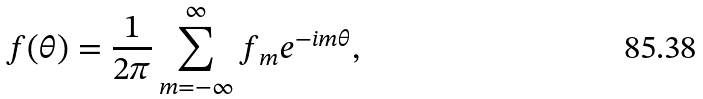<formula> <loc_0><loc_0><loc_500><loc_500>f ( \theta ) = \frac { 1 } { 2 \pi } \sum _ { m = - \infty } ^ { \infty } f _ { m } e ^ { - i m \theta } ,</formula> 